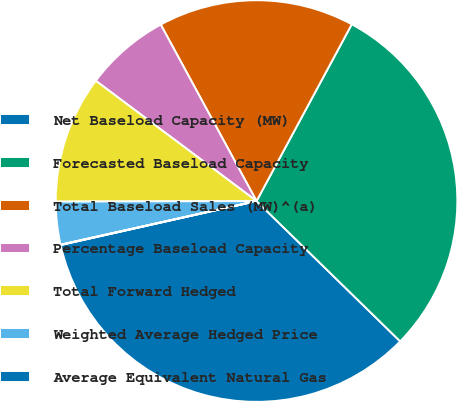Convert chart to OTSL. <chart><loc_0><loc_0><loc_500><loc_500><pie_chart><fcel>Net Baseload Capacity (MW)<fcel>Forecasted Baseload Capacity<fcel>Total Baseload Sales (MW)^(a)<fcel>Percentage Baseload Capacity<fcel>Total Forward Hedged<fcel>Weighted Average Hedged Price<fcel>Average Equivalent Natural Gas<nl><fcel>34.17%<fcel>29.45%<fcel>15.78%<fcel>6.86%<fcel>10.27%<fcel>3.44%<fcel>0.03%<nl></chart> 